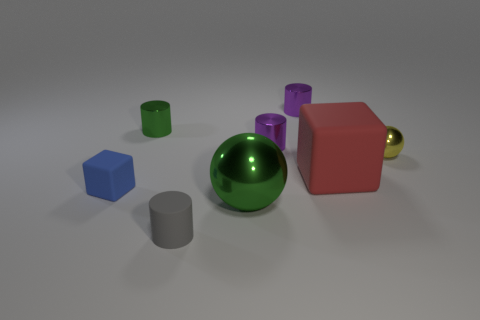What size is the red matte object?
Offer a terse response. Large. How many metallic objects are the same size as the blue matte block?
Make the answer very short. 4. How many other big things are the same shape as the yellow shiny object?
Your answer should be very brief. 1. Are there an equal number of small purple metallic cylinders that are in front of the green metal sphere and large red rubber spheres?
Offer a terse response. Yes. What is the shape of the green object that is the same size as the blue matte thing?
Make the answer very short. Cylinder. Is there a small object that has the same shape as the big green thing?
Offer a terse response. Yes. There is a small matte thing in front of the shiny sphere that is in front of the red cube; is there a large red cube that is on the right side of it?
Give a very brief answer. Yes. Are there more blocks on the right side of the tiny blue rubber cube than large green shiny balls in front of the gray object?
Provide a succinct answer. Yes. There is a gray thing that is the same size as the blue thing; what is its material?
Give a very brief answer. Rubber. How many big objects are either rubber cylinders or purple things?
Your answer should be very brief. 0. 